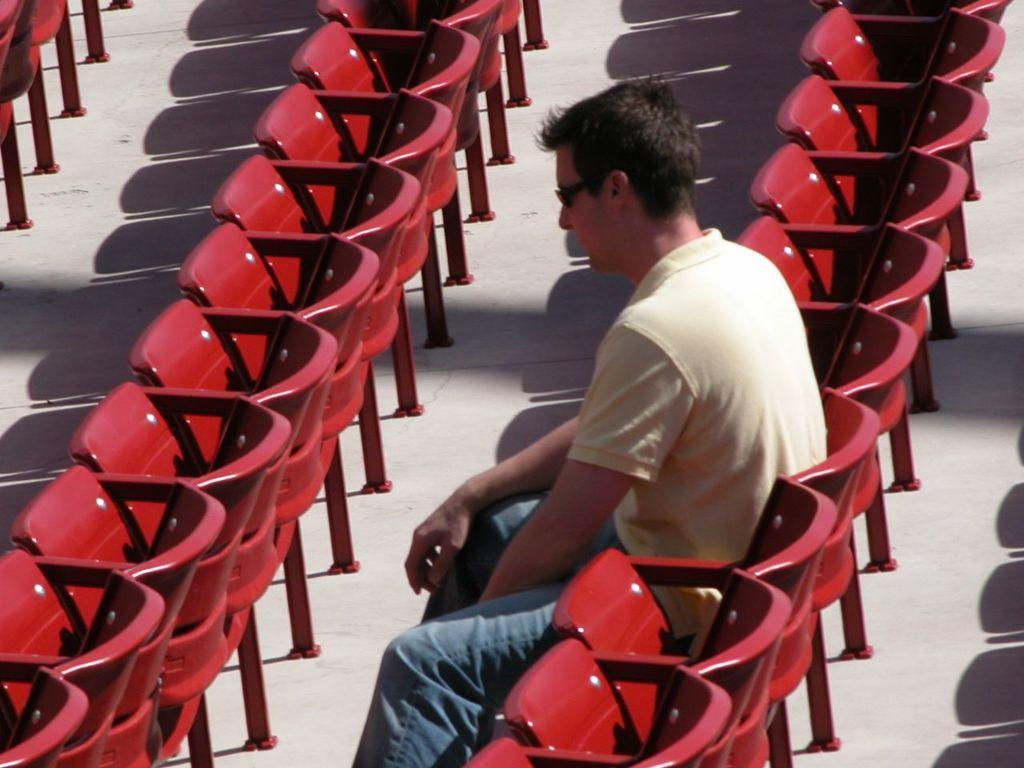What color are the chairs in the image? There are red color chairs in the image. Who is present in the image? There is a man in the image. What is the man wearing on his upper body? The man is wearing a yellow color shirt. What accessory is the man wearing on his face? The man is wearing black goggles. What is the man doing in the image? The man is sitting on a chair. How many cakes are on the table in the image? There is no table or cakes present in the image. What is the man's reaction to the disgusting smell in the image? There is no mention of a disgusting smell or any reaction from the man in the image. 